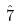<formula> <loc_0><loc_0><loc_500><loc_500>\hat { 7 }</formula> 